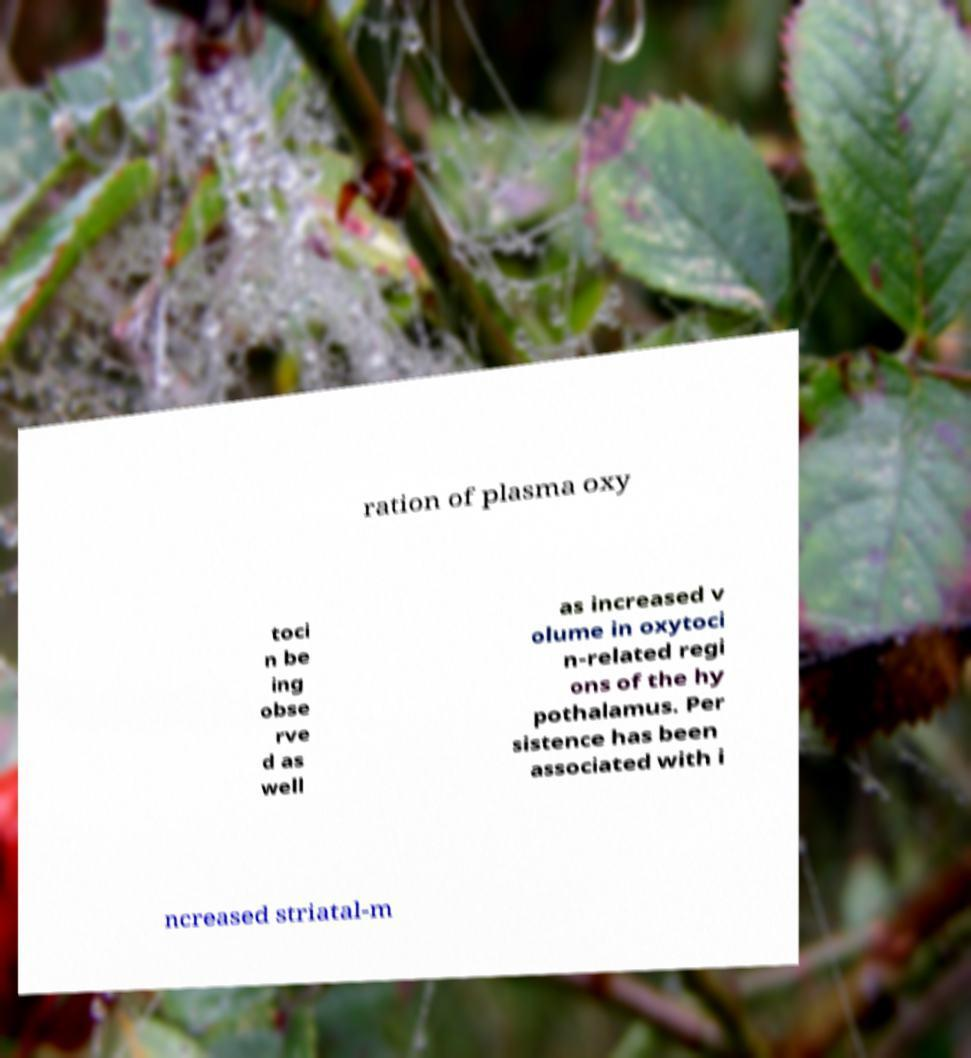Please identify and transcribe the text found in this image. ration of plasma oxy toci n be ing obse rve d as well as increased v olume in oxytoci n-related regi ons of the hy pothalamus. Per sistence has been associated with i ncreased striatal-m 